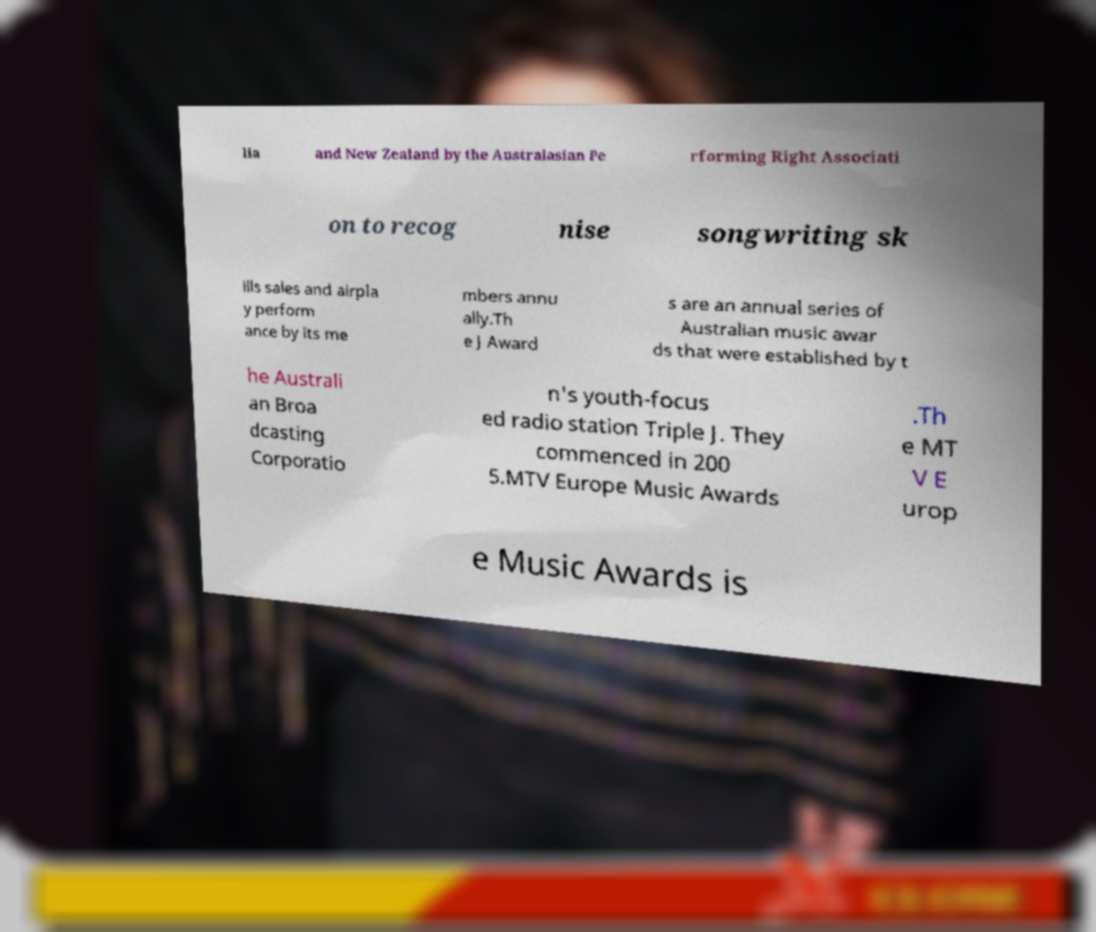Could you extract and type out the text from this image? lia and New Zealand by the Australasian Pe rforming Right Associati on to recog nise songwriting sk ills sales and airpla y perform ance by its me mbers annu ally.Th e J Award s are an annual series of Australian music awar ds that were established by t he Australi an Broa dcasting Corporatio n's youth-focus ed radio station Triple J. They commenced in 200 5.MTV Europe Music Awards .Th e MT V E urop e Music Awards is 